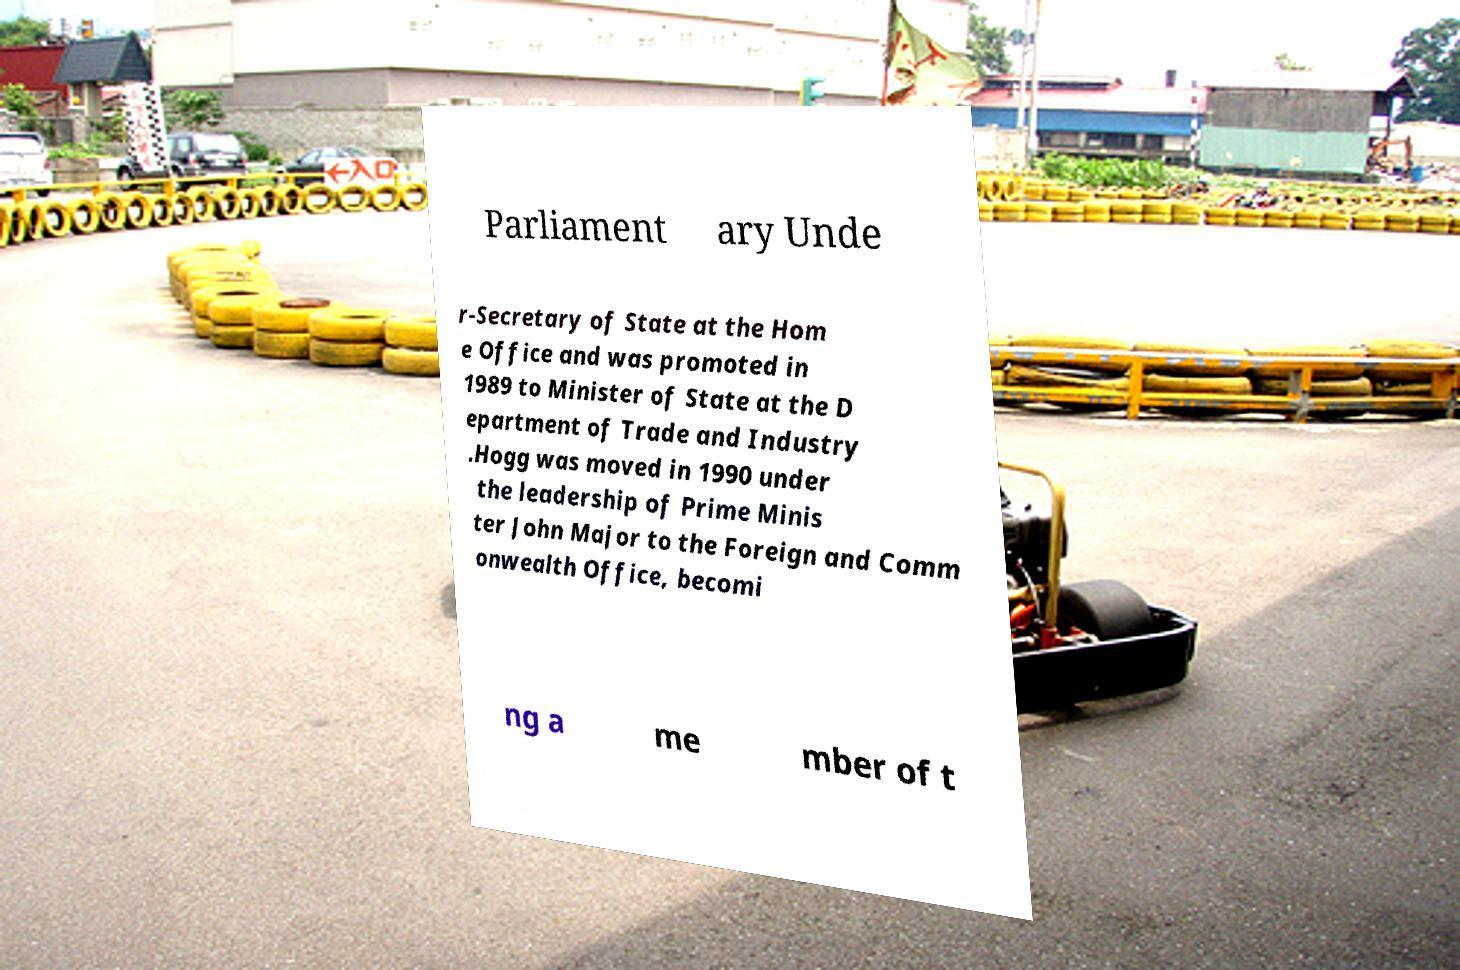Please read and relay the text visible in this image. What does it say? Parliament ary Unde r-Secretary of State at the Hom e Office and was promoted in 1989 to Minister of State at the D epartment of Trade and Industry .Hogg was moved in 1990 under the leadership of Prime Minis ter John Major to the Foreign and Comm onwealth Office, becomi ng a me mber of t 